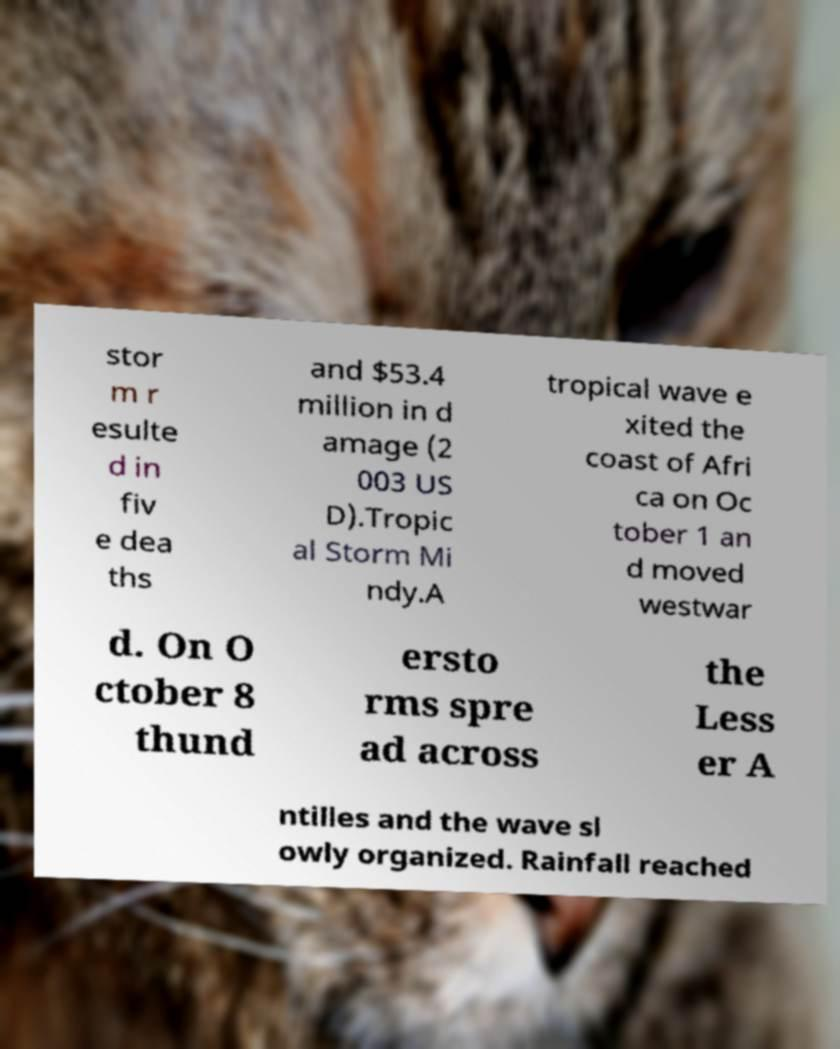Can you accurately transcribe the text from the provided image for me? stor m r esulte d in fiv e dea ths and $53.4 million in d amage (2 003 US D).Tropic al Storm Mi ndy.A tropical wave e xited the coast of Afri ca on Oc tober 1 an d moved westwar d. On O ctober 8 thund ersto rms spre ad across the Less er A ntilles and the wave sl owly organized. Rainfall reached 